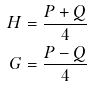Convert formula to latex. <formula><loc_0><loc_0><loc_500><loc_500>H = \frac { P + Q } { 4 } \\ G = \frac { P - Q } { 4 }</formula> 